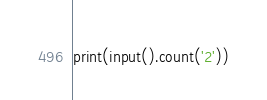<code> <loc_0><loc_0><loc_500><loc_500><_Python_>print(input().count('2'))</code> 